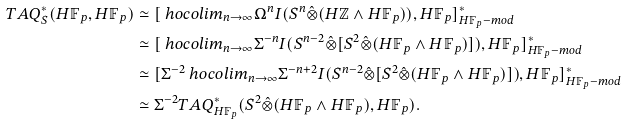Convert formula to latex. <formula><loc_0><loc_0><loc_500><loc_500>T A Q ^ { * } _ { S } ( H \mathbb { F } _ { p } , H \mathbb { F } _ { p } ) & \simeq [ \ h o c o l i m _ { n \rightarrow \infty } \Omega ^ { n } I ( S ^ { n } \hat { \otimes } ( H \mathbb { Z } \wedge H \mathbb { F } _ { p } ) ) , H \mathbb { F } _ { p } ] ^ { * } _ { H \mathbb { F } _ { p } - m o d } \\ & \simeq [ \ h o c o l i m _ { n \rightarrow \infty } \Sigma ^ { - n } I ( S ^ { n - 2 } \hat { \otimes } [ S ^ { 2 } \hat { \otimes } ( H \mathbb { F } _ { p } \wedge H \mathbb { F } _ { p } ) ] ) , H \mathbb { F } _ { p } ] ^ { * } _ { H \mathbb { F } _ { p } - m o d } \\ & \simeq [ \Sigma ^ { - 2 } \ h o c o l i m _ { n \rightarrow \infty } \Sigma ^ { - n + 2 } I ( S ^ { n - 2 } \hat { \otimes } [ S ^ { 2 } \hat { \otimes } ( H \mathbb { F } _ { p } \wedge H \mathbb { F } _ { p } ) ] ) , H \mathbb { F } _ { p } ] ^ { * } _ { H \mathbb { F } _ { p } - m o d } \\ & \simeq \Sigma ^ { - 2 } T A Q ^ { * } _ { H \mathbb { F } _ { p } } ( S ^ { 2 } \hat { \otimes } ( H \mathbb { F } _ { p } \wedge H \mathbb { F } _ { p } ) , H \mathbb { F } _ { p } ) .</formula> 